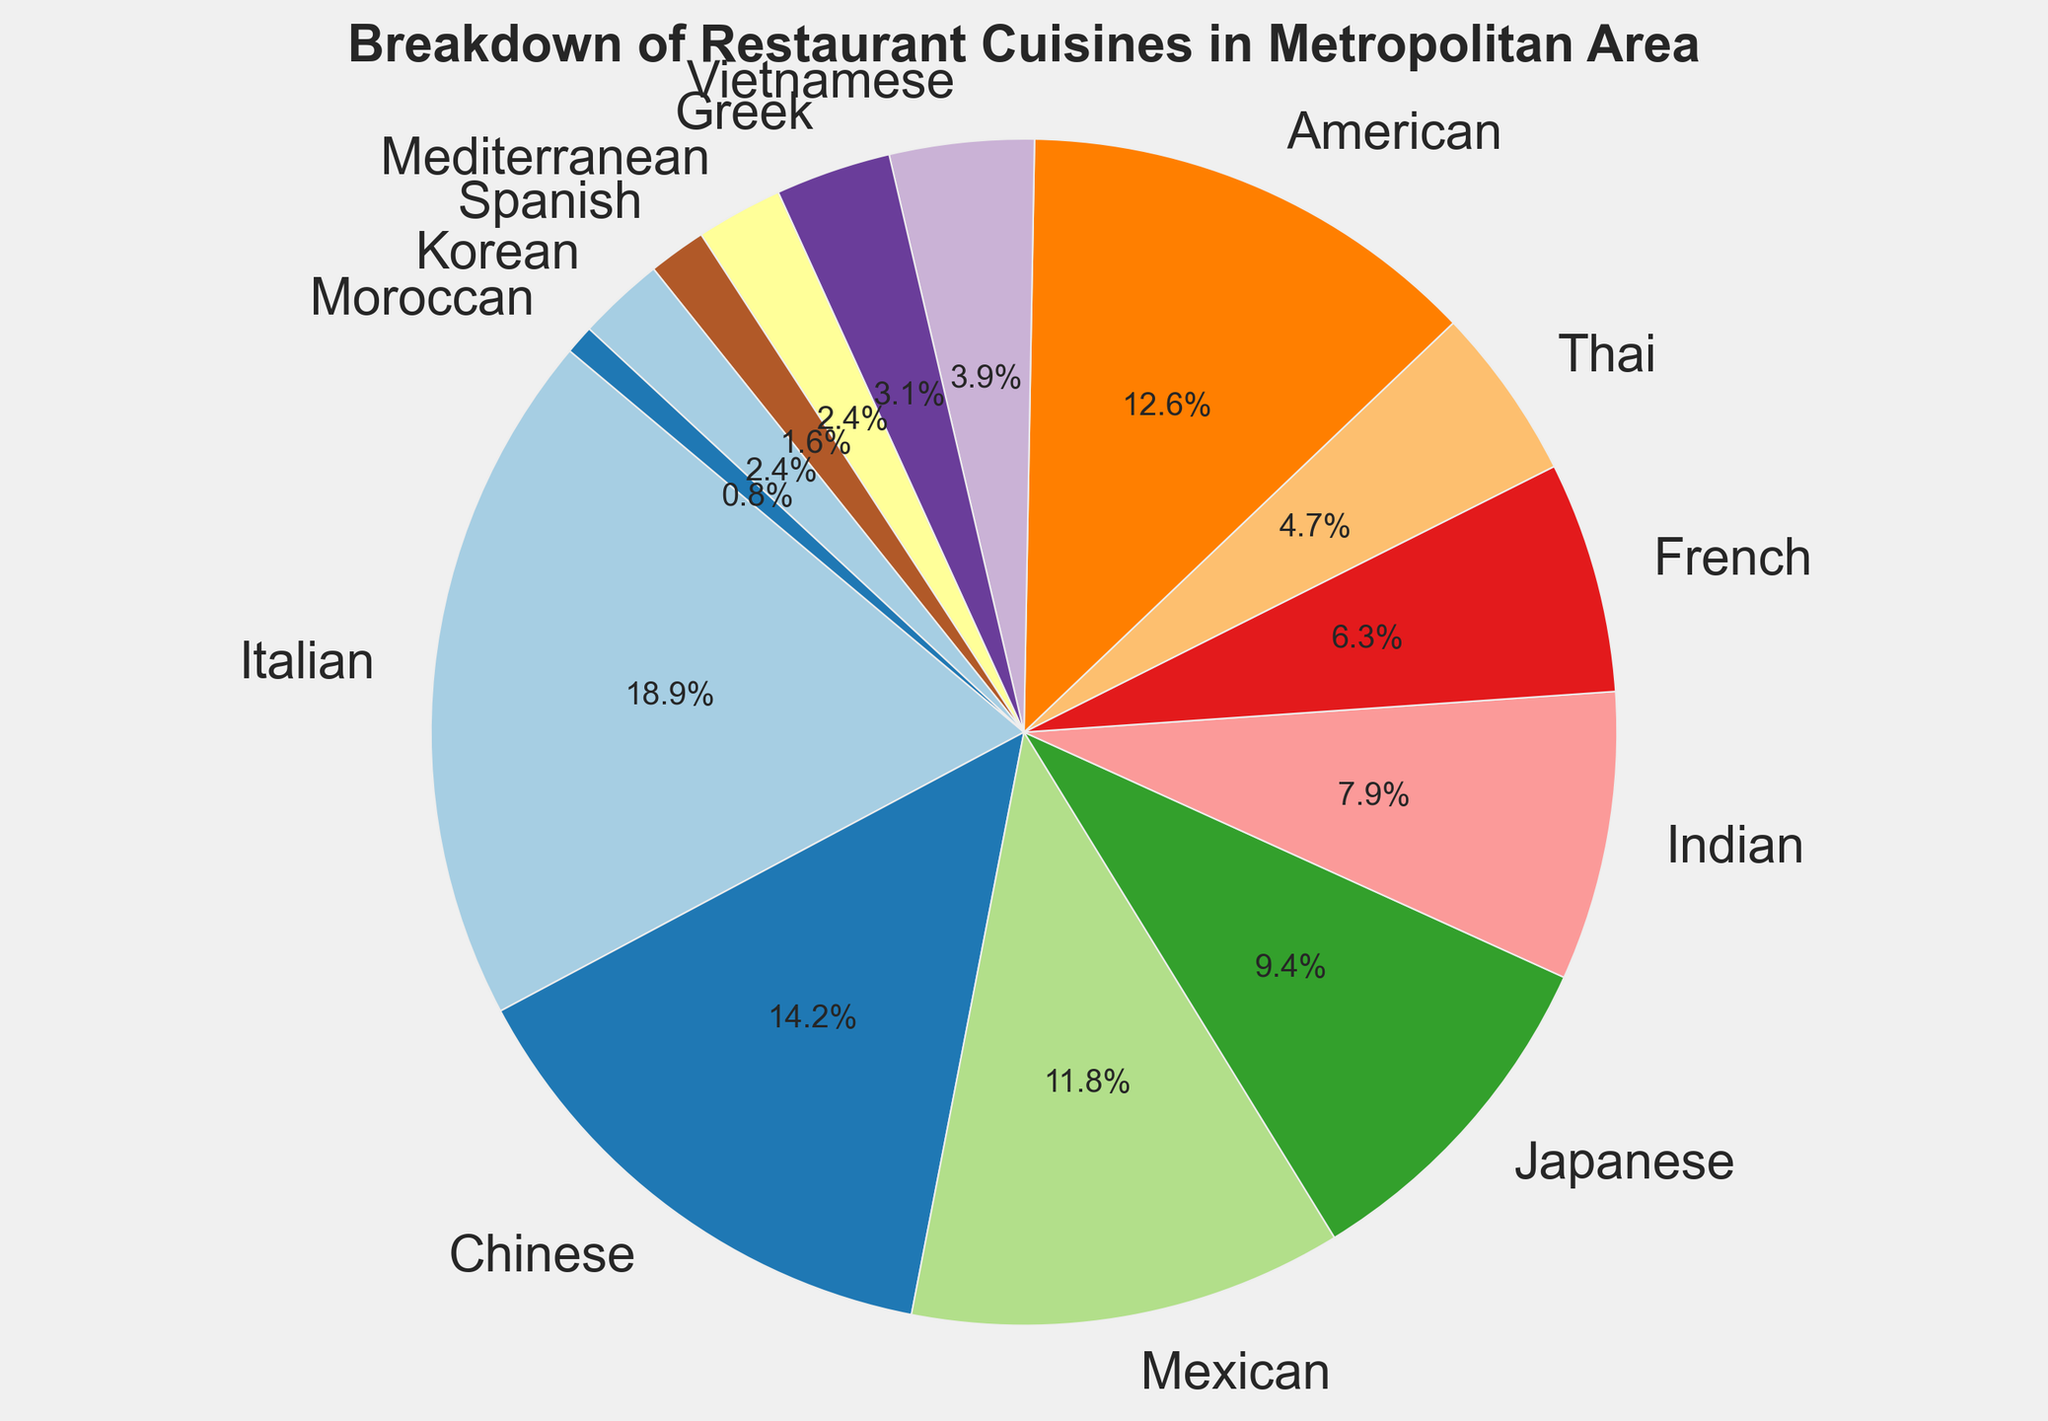Which cuisine has the highest representation on the chart? Look for the largest segment in the pie chart to identify the cuisine with the highest count.
Answer: Italian Which cuisine has the smallest representation on the chart? Look for the smallest segment in the pie chart to identify the cuisine with the lowest count.
Answer: Moroccan What is the combined percentage of Chinese and American cuisines? Sum up the percentages for Chinese and American cuisines as shown on the pie chart.
Answer: 25.3% Which cuisines have more representation compared to Thai cuisine? Compare the size of the Thai segment with other segments in the pie chart to see which ones are larger. The segments larger than Thai would be American, Italian, Chinese, Mexican, Japanese, and Indian.
Answer: American, Italian, Chinese, Mexican, Japanese, Indian Do French and Greek cuisines together make up more than 10% of the total? Sum the percentages for French and Greek cuisines, then check if this value is greater than 10%. They are French (6.8%) and Greek (3.4%), so sum them up to get 10.2%.
Answer: Yes What is the difference in representation between Italian and Japanese cuisines? Find the percentages for Italian and Japanese cuisines, then subtract the smaller percentage (Japanese) from the larger percentage (Italian). They are Italian (27.3%) and Japanese (13.6%).
Answer: 13.7% Which cuisine's segment is similar in size and color to Mexican cuisine? Look for a segment that is visually similar in both size and color to the Mexican cuisine segment. The American segment is most similar both visually and in count (as they are quite close to each other).
Answer: American How much more represented is Italian cuisine compared to Indian cuisine? Subtract the percentage of Indian cuisine (11.4%) from the percentage of Italian cuisine (27.3%) to find the difference.
Answer: 15.9% Which two cuisines have the closest representation and what are their percentages? Scan the pie chart for two segments with similar sizes and compare their percentages. The American (18.2%) and Mexican (17%) cuisines have the closest percentages.
Answer: American (18.2%), Mexican (17%) Are Korean and Mediterranean cuisines more represented than Vietnamese cuisine together? Sum the percentages of Korean and Mediterranean cuisines (3.4% + 3.4% = 6.8%) and compare it with the Vietnamese cuisine percentage (5.7%).
Answer: Yes 